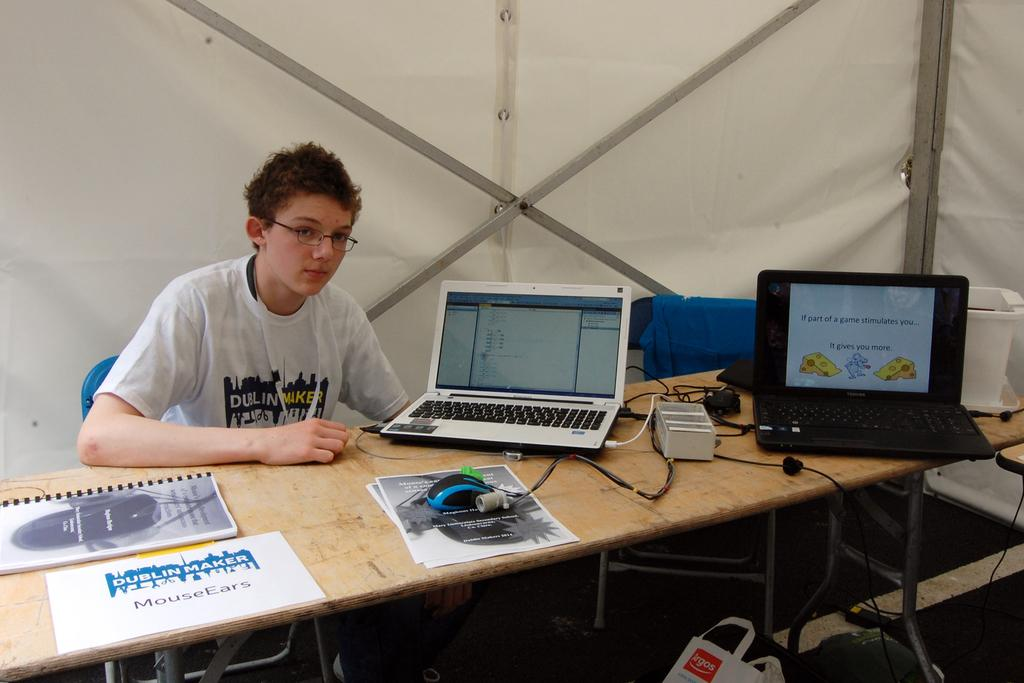<image>
Describe the image concisely. a young man sitting at a table with two laptops and a paper infront of him that reads mouse ears 